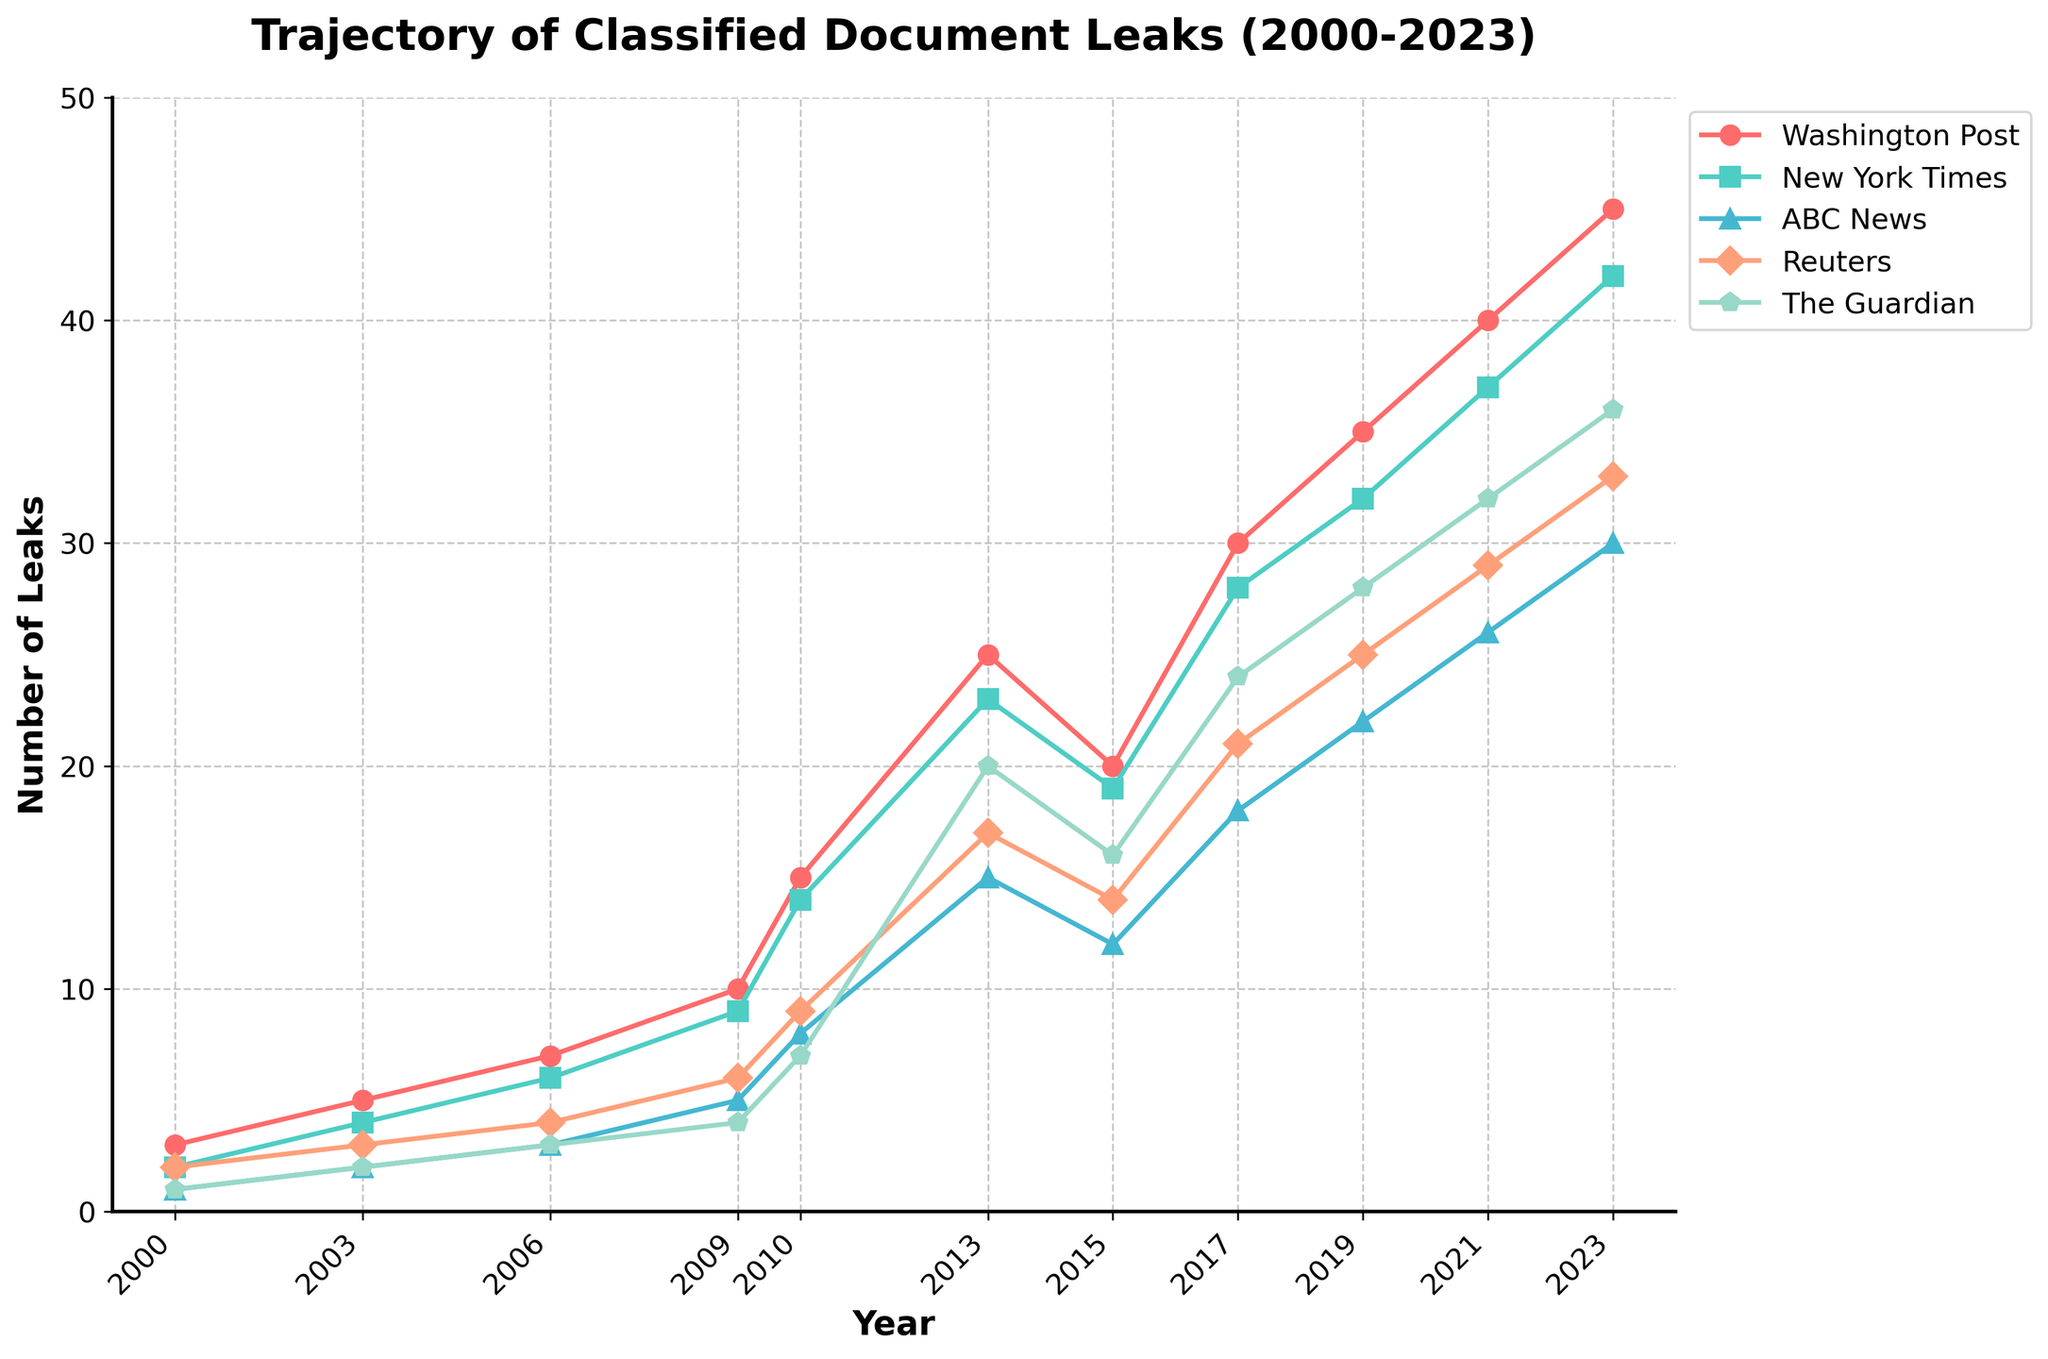What year did the Washington Post report the highest number of classified document leaks? Identify the point on the Washington Post line that reaches the highest value, which occurs in 2023.
Answer: 2023 In which years did Reuters report more classified document leaks than ABC News? Compare the values for Reuters and ABC News in each year. Reuters has higher values in 2009, 2010, 2013, 2017, 2019, 2021, and 2023.
Answer: 2009, 2010, 2013, 2017, 2019, 2021, 2023 Which news outlet saw the steepest increase in reported classified leaks between 2000 and 2013? Calculate the increase for each news outlet by subtracting the 2000 value from the 2013 value. The increases are Washington Post (25-3=22), New York Times (23-2=21), ABC News (15-1=14), Reuters (17-2=15), and The Guardian (20-1=19). The steepest increase is for the Washington Post with 22.
Answer: Washington Post How many more classified document leaks did The Guardian report in 2023 compared to 2015? Subtract The Guardian's value for 2015 from its value for 2023: 36 - 16 = 20.
Answer: 20 Between 2009 and 2015, which news outlet reported the fewest total number of classified document leaks? Sum the values from 2009, 2010, 2013, and 2015 for each outlet. The sums are Washington Post (10+15+25+20=70), New York Times (9+14+23+19=65), ABC News (5+8+15+12=40), Reuters (6+9+17+14=46), The Guardian (4+7+20+16=47). ABC News has the lowest total with 40.
Answer: ABC News How many classified document leaks did the New York Times report in total over the period 2000 to 2023? Add the New York Times values for all years: 2 + 4 + 6 + 9 + 14 + 23 + 19 + 28 + 32 + 37 + 42 = 216.
Answer: 216 Which year shows equal numbers of classified document leaks reported by both The Guardian and Reuters? Find the year where The Guardian's value equals Reuters' value. In 2000, both reported 1 leak.
Answer: 2000 What is the average number of leaks reported by ABC News from 2000 to 2023? Sum the ABC News values and divide by the number of years: (1 + 2 + 3 + 5 + 8 + 15 + 12 + 18 + 22 + 26 + 30) / 11 ≈ 15.64.
Answer: 15.64 